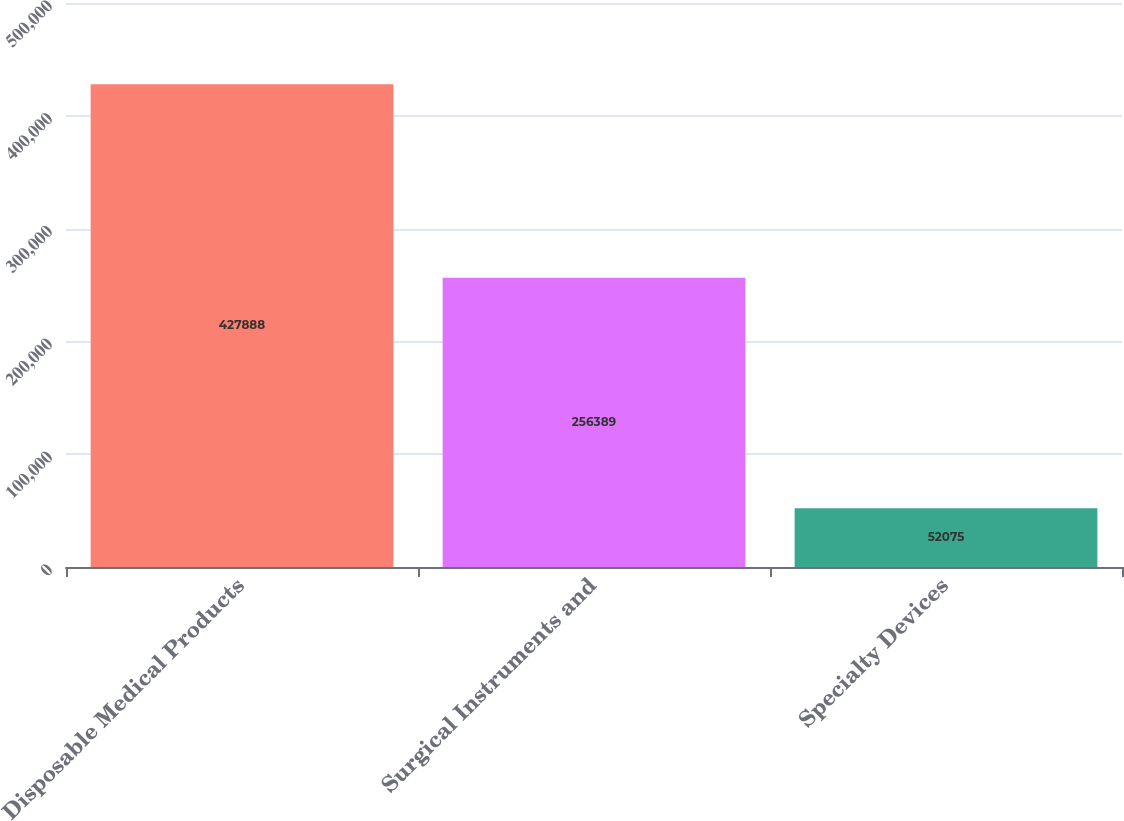Convert chart to OTSL. <chart><loc_0><loc_0><loc_500><loc_500><bar_chart><fcel>Disposable Medical Products<fcel>Surgical Instruments and<fcel>Specialty Devices<nl><fcel>427888<fcel>256389<fcel>52075<nl></chart> 